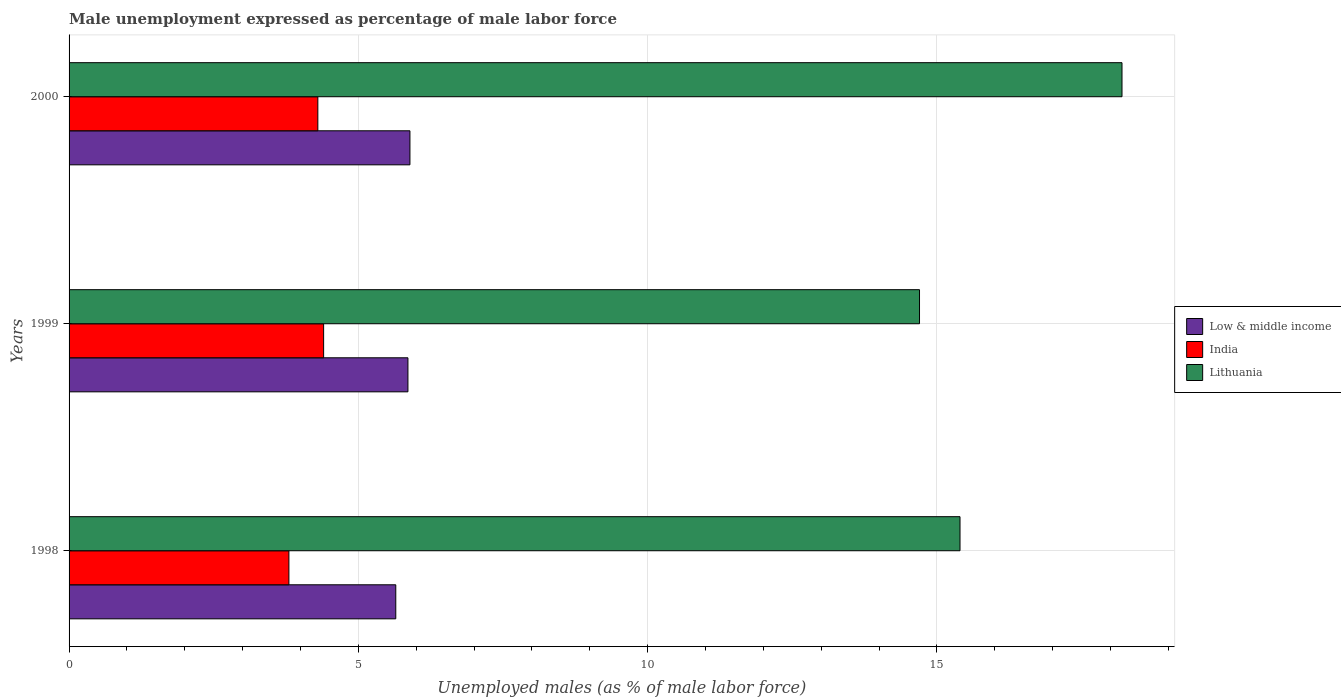How many different coloured bars are there?
Offer a terse response. 3. How many groups of bars are there?
Your response must be concise. 3. How many bars are there on the 2nd tick from the top?
Make the answer very short. 3. What is the label of the 1st group of bars from the top?
Provide a succinct answer. 2000. What is the unemployment in males in in India in 1999?
Give a very brief answer. 4.4. Across all years, what is the maximum unemployment in males in in Low & middle income?
Your answer should be compact. 5.89. Across all years, what is the minimum unemployment in males in in Lithuania?
Your answer should be compact. 14.7. In which year was the unemployment in males in in Lithuania minimum?
Provide a short and direct response. 1999. What is the total unemployment in males in in India in the graph?
Give a very brief answer. 12.5. What is the difference between the unemployment in males in in Low & middle income in 1998 and that in 1999?
Make the answer very short. -0.21. What is the difference between the unemployment in males in in Low & middle income in 1998 and the unemployment in males in in Lithuania in 1999?
Offer a very short reply. -9.05. What is the average unemployment in males in in Lithuania per year?
Your response must be concise. 16.1. In the year 1998, what is the difference between the unemployment in males in in Low & middle income and unemployment in males in in India?
Your answer should be very brief. 1.85. In how many years, is the unemployment in males in in Lithuania greater than 17 %?
Make the answer very short. 1. What is the ratio of the unemployment in males in in Lithuania in 1998 to that in 1999?
Make the answer very short. 1.05. Is the unemployment in males in in Lithuania in 1999 less than that in 2000?
Your response must be concise. Yes. What is the difference between the highest and the second highest unemployment in males in in Low & middle income?
Provide a short and direct response. 0.03. What is the difference between the highest and the lowest unemployment in males in in Lithuania?
Provide a short and direct response. 3.5. Is the sum of the unemployment in males in in Low & middle income in 1998 and 2000 greater than the maximum unemployment in males in in India across all years?
Your response must be concise. Yes. What does the 1st bar from the top in 2000 represents?
Keep it short and to the point. Lithuania. What does the 2nd bar from the bottom in 1998 represents?
Provide a succinct answer. India. Are all the bars in the graph horizontal?
Offer a terse response. Yes. How many years are there in the graph?
Make the answer very short. 3. What is the difference between two consecutive major ticks on the X-axis?
Your answer should be compact. 5. Are the values on the major ticks of X-axis written in scientific E-notation?
Your response must be concise. No. Does the graph contain grids?
Ensure brevity in your answer.  Yes. Where does the legend appear in the graph?
Ensure brevity in your answer.  Center right. What is the title of the graph?
Ensure brevity in your answer.  Male unemployment expressed as percentage of male labor force. What is the label or title of the X-axis?
Offer a terse response. Unemployed males (as % of male labor force). What is the label or title of the Y-axis?
Offer a very short reply. Years. What is the Unemployed males (as % of male labor force) of Low & middle income in 1998?
Your answer should be very brief. 5.65. What is the Unemployed males (as % of male labor force) of India in 1998?
Your answer should be very brief. 3.8. What is the Unemployed males (as % of male labor force) in Lithuania in 1998?
Your answer should be very brief. 15.4. What is the Unemployed males (as % of male labor force) in Low & middle income in 1999?
Your answer should be compact. 5.86. What is the Unemployed males (as % of male labor force) in India in 1999?
Give a very brief answer. 4.4. What is the Unemployed males (as % of male labor force) in Lithuania in 1999?
Provide a short and direct response. 14.7. What is the Unemployed males (as % of male labor force) in Low & middle income in 2000?
Your response must be concise. 5.89. What is the Unemployed males (as % of male labor force) of India in 2000?
Give a very brief answer. 4.3. What is the Unemployed males (as % of male labor force) of Lithuania in 2000?
Give a very brief answer. 18.2. Across all years, what is the maximum Unemployed males (as % of male labor force) in Low & middle income?
Your answer should be very brief. 5.89. Across all years, what is the maximum Unemployed males (as % of male labor force) of India?
Give a very brief answer. 4.4. Across all years, what is the maximum Unemployed males (as % of male labor force) in Lithuania?
Provide a succinct answer. 18.2. Across all years, what is the minimum Unemployed males (as % of male labor force) of Low & middle income?
Provide a succinct answer. 5.65. Across all years, what is the minimum Unemployed males (as % of male labor force) of India?
Your answer should be compact. 3.8. Across all years, what is the minimum Unemployed males (as % of male labor force) in Lithuania?
Your response must be concise. 14.7. What is the total Unemployed males (as % of male labor force) in Low & middle income in the graph?
Offer a terse response. 17.4. What is the total Unemployed males (as % of male labor force) in India in the graph?
Offer a terse response. 12.5. What is the total Unemployed males (as % of male labor force) of Lithuania in the graph?
Your answer should be very brief. 48.3. What is the difference between the Unemployed males (as % of male labor force) of Low & middle income in 1998 and that in 1999?
Your answer should be very brief. -0.21. What is the difference between the Unemployed males (as % of male labor force) of Lithuania in 1998 and that in 1999?
Offer a terse response. 0.7. What is the difference between the Unemployed males (as % of male labor force) in Low & middle income in 1998 and that in 2000?
Make the answer very short. -0.24. What is the difference between the Unemployed males (as % of male labor force) of India in 1998 and that in 2000?
Give a very brief answer. -0.5. What is the difference between the Unemployed males (as % of male labor force) in Lithuania in 1998 and that in 2000?
Provide a short and direct response. -2.8. What is the difference between the Unemployed males (as % of male labor force) in Low & middle income in 1999 and that in 2000?
Provide a short and direct response. -0.03. What is the difference between the Unemployed males (as % of male labor force) in India in 1999 and that in 2000?
Offer a terse response. 0.1. What is the difference between the Unemployed males (as % of male labor force) in Low & middle income in 1998 and the Unemployed males (as % of male labor force) in India in 1999?
Give a very brief answer. 1.25. What is the difference between the Unemployed males (as % of male labor force) of Low & middle income in 1998 and the Unemployed males (as % of male labor force) of Lithuania in 1999?
Make the answer very short. -9.05. What is the difference between the Unemployed males (as % of male labor force) of Low & middle income in 1998 and the Unemployed males (as % of male labor force) of India in 2000?
Make the answer very short. 1.35. What is the difference between the Unemployed males (as % of male labor force) in Low & middle income in 1998 and the Unemployed males (as % of male labor force) in Lithuania in 2000?
Make the answer very short. -12.55. What is the difference between the Unemployed males (as % of male labor force) in India in 1998 and the Unemployed males (as % of male labor force) in Lithuania in 2000?
Your answer should be very brief. -14.4. What is the difference between the Unemployed males (as % of male labor force) of Low & middle income in 1999 and the Unemployed males (as % of male labor force) of India in 2000?
Your response must be concise. 1.56. What is the difference between the Unemployed males (as % of male labor force) of Low & middle income in 1999 and the Unemployed males (as % of male labor force) of Lithuania in 2000?
Your answer should be very brief. -12.34. What is the difference between the Unemployed males (as % of male labor force) of India in 1999 and the Unemployed males (as % of male labor force) of Lithuania in 2000?
Keep it short and to the point. -13.8. What is the average Unemployed males (as % of male labor force) in Low & middle income per year?
Offer a terse response. 5.8. What is the average Unemployed males (as % of male labor force) in India per year?
Provide a short and direct response. 4.17. In the year 1998, what is the difference between the Unemployed males (as % of male labor force) in Low & middle income and Unemployed males (as % of male labor force) in India?
Provide a short and direct response. 1.85. In the year 1998, what is the difference between the Unemployed males (as % of male labor force) of Low & middle income and Unemployed males (as % of male labor force) of Lithuania?
Keep it short and to the point. -9.75. In the year 1999, what is the difference between the Unemployed males (as % of male labor force) in Low & middle income and Unemployed males (as % of male labor force) in India?
Your response must be concise. 1.46. In the year 1999, what is the difference between the Unemployed males (as % of male labor force) in Low & middle income and Unemployed males (as % of male labor force) in Lithuania?
Your answer should be compact. -8.84. In the year 2000, what is the difference between the Unemployed males (as % of male labor force) in Low & middle income and Unemployed males (as % of male labor force) in India?
Offer a very short reply. 1.59. In the year 2000, what is the difference between the Unemployed males (as % of male labor force) in Low & middle income and Unemployed males (as % of male labor force) in Lithuania?
Your answer should be very brief. -12.31. What is the ratio of the Unemployed males (as % of male labor force) of Low & middle income in 1998 to that in 1999?
Your response must be concise. 0.96. What is the ratio of the Unemployed males (as % of male labor force) of India in 1998 to that in 1999?
Your response must be concise. 0.86. What is the ratio of the Unemployed males (as % of male labor force) in Lithuania in 1998 to that in 1999?
Your response must be concise. 1.05. What is the ratio of the Unemployed males (as % of male labor force) in Low & middle income in 1998 to that in 2000?
Your response must be concise. 0.96. What is the ratio of the Unemployed males (as % of male labor force) of India in 1998 to that in 2000?
Offer a very short reply. 0.88. What is the ratio of the Unemployed males (as % of male labor force) in Lithuania in 1998 to that in 2000?
Your answer should be very brief. 0.85. What is the ratio of the Unemployed males (as % of male labor force) of Low & middle income in 1999 to that in 2000?
Offer a very short reply. 0.99. What is the ratio of the Unemployed males (as % of male labor force) in India in 1999 to that in 2000?
Offer a very short reply. 1.02. What is the ratio of the Unemployed males (as % of male labor force) in Lithuania in 1999 to that in 2000?
Keep it short and to the point. 0.81. What is the difference between the highest and the second highest Unemployed males (as % of male labor force) in Low & middle income?
Offer a very short reply. 0.03. What is the difference between the highest and the second highest Unemployed males (as % of male labor force) in India?
Your response must be concise. 0.1. What is the difference between the highest and the second highest Unemployed males (as % of male labor force) of Lithuania?
Your response must be concise. 2.8. What is the difference between the highest and the lowest Unemployed males (as % of male labor force) of Low & middle income?
Provide a succinct answer. 0.24. What is the difference between the highest and the lowest Unemployed males (as % of male labor force) of India?
Give a very brief answer. 0.6. What is the difference between the highest and the lowest Unemployed males (as % of male labor force) of Lithuania?
Provide a succinct answer. 3.5. 